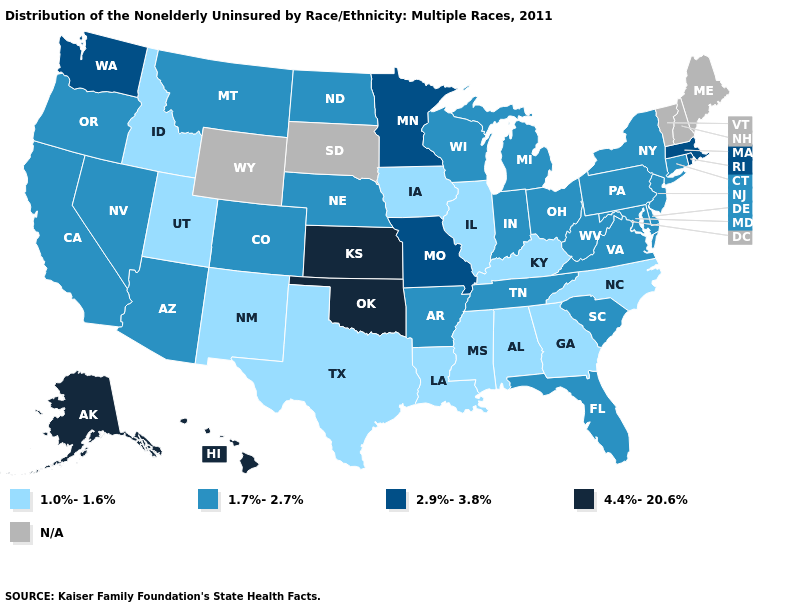Among the states that border New Mexico , does Colorado have the lowest value?
Keep it brief. No. Name the states that have a value in the range 2.9%-3.8%?
Keep it brief. Massachusetts, Minnesota, Missouri, Rhode Island, Washington. What is the highest value in the USA?
Quick response, please. 4.4%-20.6%. What is the lowest value in the USA?
Write a very short answer. 1.0%-1.6%. Is the legend a continuous bar?
Give a very brief answer. No. How many symbols are there in the legend?
Answer briefly. 5. What is the lowest value in the MidWest?
Keep it brief. 1.0%-1.6%. What is the value of Texas?
Short answer required. 1.0%-1.6%. What is the value of Nebraska?
Write a very short answer. 1.7%-2.7%. 